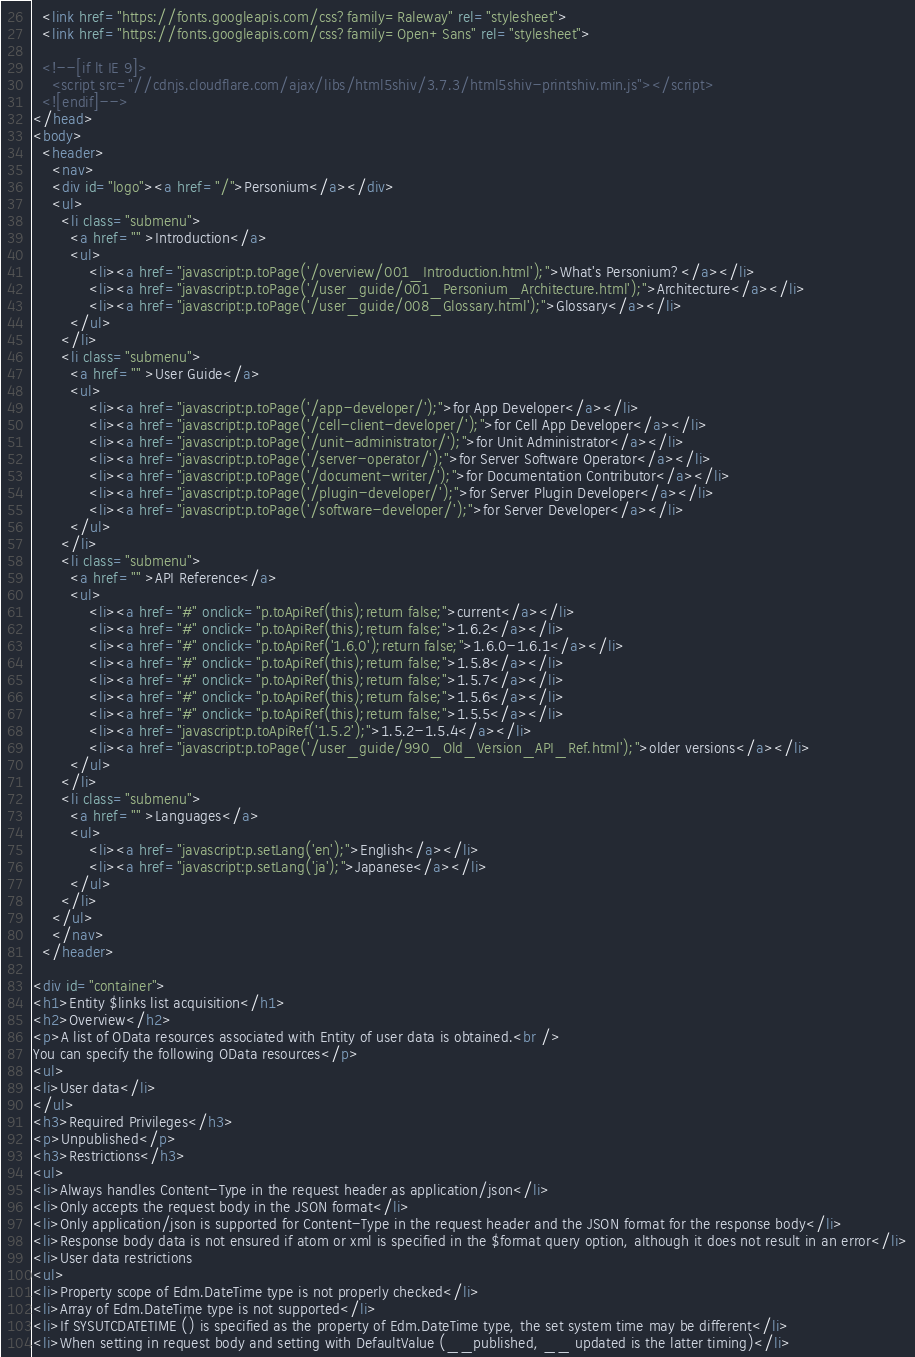<code> <loc_0><loc_0><loc_500><loc_500><_HTML_>  <link href="https://fonts.googleapis.com/css?family=Raleway" rel="stylesheet">
  <link href="https://fonts.googleapis.com/css?family=Open+Sans" rel="stylesheet">
  
  <!--[if lt IE 9]>
    <script src="//cdnjs.cloudflare.com/ajax/libs/html5shiv/3.7.3/html5shiv-printshiv.min.js"></script>
  <![endif]-->
</head>
<body>
  <header>
    <nav>
    <div id="logo"><a href="/">Personium</a></div>
    <ul>
      <li class="submenu">
        <a href="" >Introduction</a>
        <ul>
            <li><a href="javascript:p.toPage('/overview/001_Introduction.html');">What's Personium?</a></li>
            <li><a href="javascript:p.toPage('/user_guide/001_Personium_Architecture.html');">Architecture</a></li>
            <li><a href="javascript:p.toPage('/user_guide/008_Glossary.html');">Glossary</a></li>
        </ul>
      </li>
      <li class="submenu">
        <a href="" >User Guide</a>
        <ul>
            <li><a href="javascript:p.toPage('/app-developer/');">for App Developer</a></li>
            <li><a href="javascript:p.toPage('/cell-client-developer/');">for Cell App Developer</a></li>
            <li><a href="javascript:p.toPage('/unit-administrator/');">for Unit Administrator</a></li>
            <li><a href="javascript:p.toPage('/server-operator/');">for Server Software Operator</a></li>
            <li><a href="javascript:p.toPage('/document-writer/');">for Documentation Contributor</a></li>
            <li><a href="javascript:p.toPage('/plugin-developer/');">for Server Plugin Developer</a></li>
            <li><a href="javascript:p.toPage('/software-developer/');">for Server Developer</a></li>
        </ul>
      </li>
      <li class="submenu">
        <a href="" >API Reference</a>
        <ul>
            <li><a href="#" onclick="p.toApiRef(this);return false;">current</a></li>
            <li><a href="#" onclick="p.toApiRef(this);return false;">1.6.2</a></li>
            <li><a href="#" onclick="p.toApiRef('1.6.0');return false;">1.6.0-1.6.1</a></li>
            <li><a href="#" onclick="p.toApiRef(this);return false;">1.5.8</a></li>
            <li><a href="#" onclick="p.toApiRef(this);return false;">1.5.7</a></li>
            <li><a href="#" onclick="p.toApiRef(this);return false;">1.5.6</a></li>
            <li><a href="#" onclick="p.toApiRef(this);return false;">1.5.5</a></li>
            <li><a href="javascript:p.toApiRef('1.5.2');">1.5.2-1.5.4</a></li>
            <li><a href="javascript:p.toPage('/user_guide/990_Old_Version_API_Ref.html');">older versions</a></li>
        </ul>
      </li>
      <li class="submenu">
        <a href="" >Languages</a>
        <ul>
            <li><a href="javascript:p.setLang('en');">English</a></li>
            <li><a href="javascript:p.setLang('ja');">Japanese</a></li>
        </ul>
      </li>
    </ul>
    </nav>
  </header>

<div id="container">
<h1>Entity $links list acquisition</h1>
<h2>Overview</h2>
<p>A list of OData resources associated with Entity of user data is obtained.<br />
You can specify the following OData resources</p>
<ul>
<li>User data</li>
</ul>
<h3>Required Privileges</h3>
<p>Unpublished</p>
<h3>Restrictions</h3>
<ul>
<li>Always handles Content-Type in the request header as application/json</li>
<li>Only accepts the request body in the JSON format</li>
<li>Only application/json is supported for Content-Type in the request header and the JSON format for the response body</li>
<li>Response body data is not ensured if atom or xml is specified in the $format query option, although it does not result in an error</li>
<li>User data restrictions
<ul>
<li>Property scope of Edm.DateTime type is not properly checked</li>
<li>Array of Edm.DateTime type is not supported</li>
<li>If SYSUTCDATETIME () is specified as the property of Edm.DateTime type, the set system time may be different</li>
<li>When setting in request body and setting with DefaultValue (__published, __ updated is the latter timing)</li></code> 